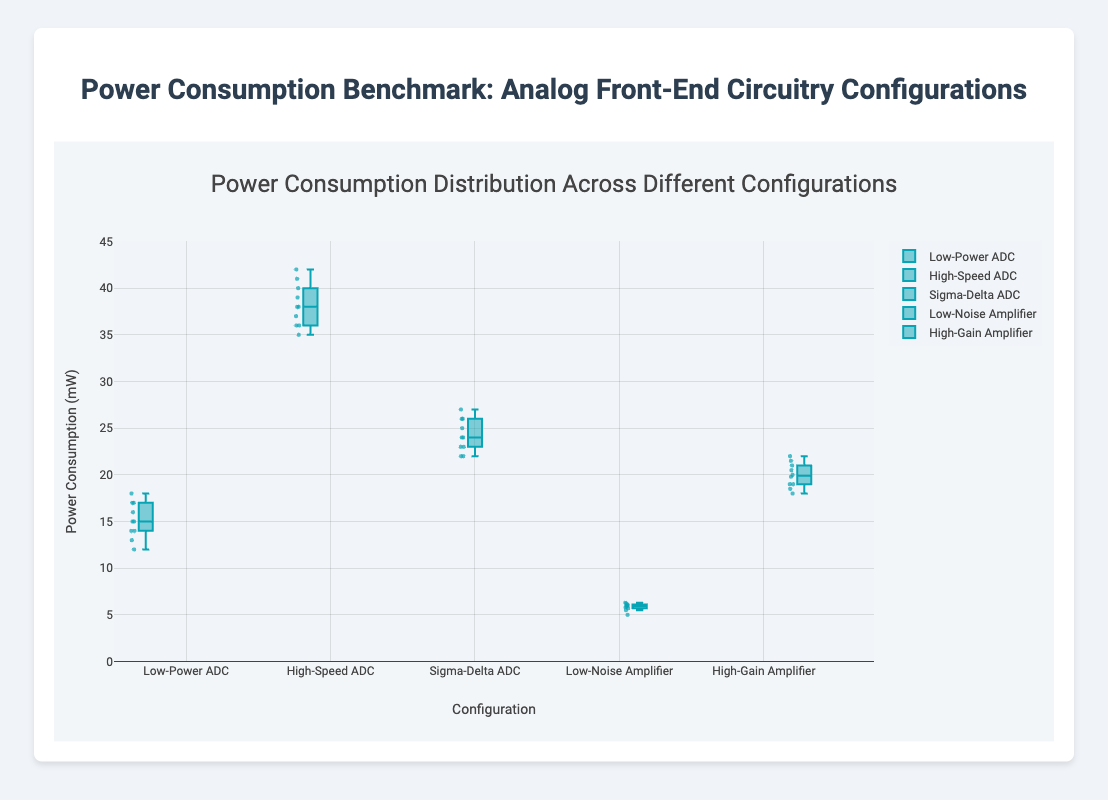What is the title of the plot? The title is usually found at the top of the plot. In this plot, it reads "Power Consumption Distribution Across Different Configurations."
Answer: Power Consumption Distribution Across Different Configurations Which configuration has the lowest median power consumption? The median in a box plot is represented by the line inside the box. The "Low-Noise Amplifier" configuration has the lowest median power consumption.
Answer: Low-Noise Amplifier What is the range of power consumption for the High-Speed ADC configuration? The range can be determined by looking at the minimum and maximum values, represented by the end of the whiskers in the box plot. For the "High-Speed ADC" configuration, the minimum is 35 mW and the maximum is 42 mW. The range is 42 - 35 = 7 mW.
Answer: 7 mW Which configuration has the most consistent power consumption values? Consistency can be assessed by the interquartile range (IQR), which is the width of the box. The narrower the box, the more consistent the values. "Low-Noise Amplifier" has the narrowest box, indicating the most consistent power consumption values.
Answer: Low-Noise Amplifier How does the power consumption of the High-Gain Amplifier compare to the Low-Power ADC? Compare the median and the interquartile ranges of both configurations. The "High-Gain Amplifier" has a median of around 20 mW, while the "Low-Power ADC" has a median of around 15 mW. The High-Gain Amplifier consumes more power than the Low-Power ADC.
Answer: High-Gain Amplifier consumes more power Which configuration has outliers in its power consumption values? Outliers in a box plot are usually marked with distinct points outside the whiskers. The "Low-Noise Amplifier" configuration has an outlier.
Answer: Low-Noise Amplifier What is the interquartile range (IQR) for the Sigma-Delta ADC configuration? The IQR is the difference between the third quartile (Q3) and the first quartile (Q1). For the "Sigma-Delta ADC," Q3 is around 26 mW and Q1 is around 23 mW. Thus, the IQR is 26 - 23 = 3 mW.
Answer: 3 mW Does any configuration have a maximum power consumption exceeding 40 mW? The maximum value can be identified by the upper whisker or any outliers outside it. "High-Speed ADC" has a maximum power consumption of 42 mW, which exceeds 40 mW.
Answer: Yes Which configuration has the highest median power consumption? The median is indicated by the line inside each box. "High-Speed ADC" has the highest median power consumption.
Answer: High-Speed ADC Compare the range of power consumption between Low-Power ADC and Sigma-Delta ADC. The range can be calculated as the difference between the maximum and minimum values shown by the whiskers of each configuration. For "Low-Power ADC," the range is 18 - 12 = 6 mW. For "Sigma-Delta ADC," the range is 27 - 22 = 5 mW.
Answer: Low-Power ADC: 6 mW, Sigma-Delta ADC: 5 mW 